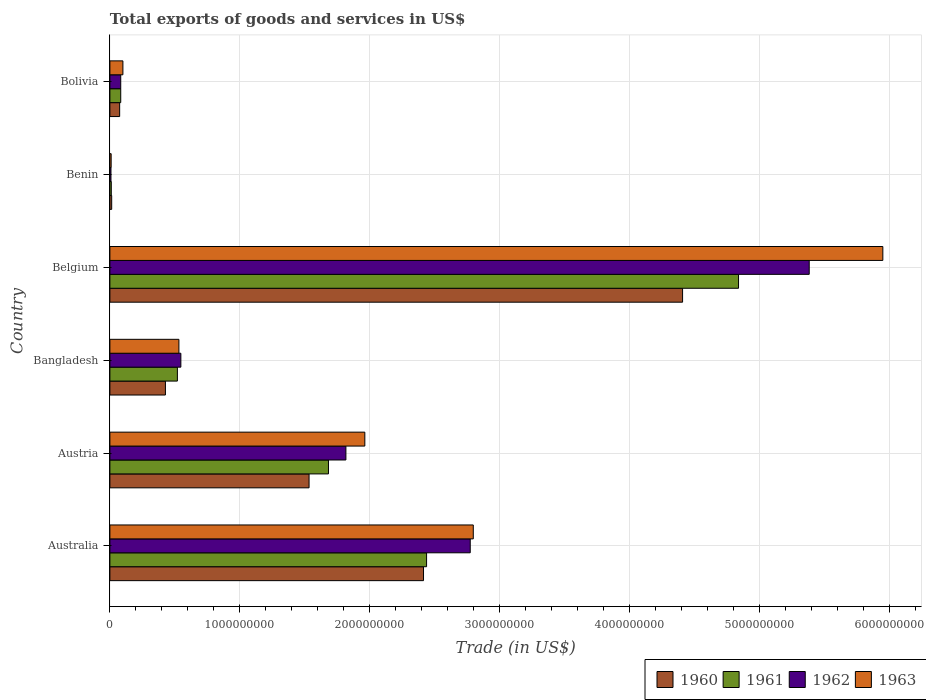How many different coloured bars are there?
Give a very brief answer. 4. How many groups of bars are there?
Keep it short and to the point. 6. Are the number of bars per tick equal to the number of legend labels?
Your answer should be compact. Yes. How many bars are there on the 2nd tick from the top?
Provide a succinct answer. 4. How many bars are there on the 3rd tick from the bottom?
Keep it short and to the point. 4. In how many cases, is the number of bars for a given country not equal to the number of legend labels?
Offer a terse response. 0. What is the total exports of goods and services in 1962 in Bangladesh?
Offer a terse response. 5.46e+08. Across all countries, what is the maximum total exports of goods and services in 1963?
Offer a very short reply. 5.95e+09. Across all countries, what is the minimum total exports of goods and services in 1963?
Keep it short and to the point. 9.70e+06. In which country was the total exports of goods and services in 1962 minimum?
Give a very brief answer. Benin. What is the total total exports of goods and services in 1962 in the graph?
Make the answer very short. 1.06e+1. What is the difference between the total exports of goods and services in 1962 in Benin and that in Bolivia?
Your answer should be very brief. -7.52e+07. What is the difference between the total exports of goods and services in 1961 in Bangladesh and the total exports of goods and services in 1963 in Australia?
Offer a terse response. -2.28e+09. What is the average total exports of goods and services in 1961 per country?
Offer a very short reply. 1.60e+09. What is the difference between the total exports of goods and services in 1960 and total exports of goods and services in 1962 in Austria?
Provide a succinct answer. -2.84e+08. In how many countries, is the total exports of goods and services in 1962 greater than 2600000000 US$?
Give a very brief answer. 2. What is the ratio of the total exports of goods and services in 1963 in Australia to that in Benin?
Your response must be concise. 288.2. Is the difference between the total exports of goods and services in 1960 in Belgium and Benin greater than the difference between the total exports of goods and services in 1962 in Belgium and Benin?
Keep it short and to the point. No. What is the difference between the highest and the second highest total exports of goods and services in 1960?
Offer a terse response. 1.99e+09. What is the difference between the highest and the lowest total exports of goods and services in 1962?
Make the answer very short. 5.37e+09. Is it the case that in every country, the sum of the total exports of goods and services in 1961 and total exports of goods and services in 1963 is greater than the sum of total exports of goods and services in 1962 and total exports of goods and services in 1960?
Your answer should be compact. No. What does the 1st bar from the top in Australia represents?
Provide a short and direct response. 1963. What does the 4th bar from the bottom in Bangladesh represents?
Offer a terse response. 1963. How many bars are there?
Provide a succinct answer. 24. How many countries are there in the graph?
Provide a short and direct response. 6. What is the difference between two consecutive major ticks on the X-axis?
Your answer should be compact. 1.00e+09. Does the graph contain any zero values?
Provide a short and direct response. No. Where does the legend appear in the graph?
Offer a terse response. Bottom right. What is the title of the graph?
Your answer should be compact. Total exports of goods and services in US$. What is the label or title of the X-axis?
Your answer should be compact. Trade (in US$). What is the label or title of the Y-axis?
Provide a short and direct response. Country. What is the Trade (in US$) in 1960 in Australia?
Your answer should be very brief. 2.41e+09. What is the Trade (in US$) in 1961 in Australia?
Offer a terse response. 2.44e+09. What is the Trade (in US$) in 1962 in Australia?
Give a very brief answer. 2.77e+09. What is the Trade (in US$) of 1963 in Australia?
Your response must be concise. 2.80e+09. What is the Trade (in US$) in 1960 in Austria?
Provide a succinct answer. 1.53e+09. What is the Trade (in US$) of 1961 in Austria?
Your answer should be very brief. 1.68e+09. What is the Trade (in US$) in 1962 in Austria?
Your response must be concise. 1.82e+09. What is the Trade (in US$) of 1963 in Austria?
Offer a terse response. 1.96e+09. What is the Trade (in US$) in 1960 in Bangladesh?
Provide a succinct answer. 4.27e+08. What is the Trade (in US$) in 1961 in Bangladesh?
Your response must be concise. 5.19e+08. What is the Trade (in US$) in 1962 in Bangladesh?
Provide a succinct answer. 5.46e+08. What is the Trade (in US$) in 1963 in Bangladesh?
Your answer should be very brief. 5.31e+08. What is the Trade (in US$) in 1960 in Belgium?
Your answer should be compact. 4.41e+09. What is the Trade (in US$) of 1961 in Belgium?
Offer a terse response. 4.84e+09. What is the Trade (in US$) in 1962 in Belgium?
Give a very brief answer. 5.38e+09. What is the Trade (in US$) in 1963 in Belgium?
Offer a very short reply. 5.95e+09. What is the Trade (in US$) in 1960 in Benin?
Make the answer very short. 1.39e+07. What is the Trade (in US$) in 1961 in Benin?
Make the answer very short. 1.08e+07. What is the Trade (in US$) in 1962 in Benin?
Offer a terse response. 8.32e+06. What is the Trade (in US$) in 1963 in Benin?
Ensure brevity in your answer.  9.70e+06. What is the Trade (in US$) of 1960 in Bolivia?
Offer a very short reply. 7.51e+07. What is the Trade (in US$) in 1961 in Bolivia?
Keep it short and to the point. 8.35e+07. What is the Trade (in US$) in 1962 in Bolivia?
Your answer should be very brief. 8.35e+07. What is the Trade (in US$) in 1963 in Bolivia?
Give a very brief answer. 1.00e+08. Across all countries, what is the maximum Trade (in US$) in 1960?
Offer a terse response. 4.41e+09. Across all countries, what is the maximum Trade (in US$) of 1961?
Give a very brief answer. 4.84e+09. Across all countries, what is the maximum Trade (in US$) in 1962?
Offer a very short reply. 5.38e+09. Across all countries, what is the maximum Trade (in US$) in 1963?
Your response must be concise. 5.95e+09. Across all countries, what is the minimum Trade (in US$) of 1960?
Ensure brevity in your answer.  1.39e+07. Across all countries, what is the minimum Trade (in US$) of 1961?
Make the answer very short. 1.08e+07. Across all countries, what is the minimum Trade (in US$) of 1962?
Make the answer very short. 8.32e+06. Across all countries, what is the minimum Trade (in US$) in 1963?
Your answer should be compact. 9.70e+06. What is the total Trade (in US$) of 1960 in the graph?
Your response must be concise. 8.87e+09. What is the total Trade (in US$) in 1961 in the graph?
Offer a terse response. 9.57e+09. What is the total Trade (in US$) of 1962 in the graph?
Offer a very short reply. 1.06e+1. What is the total Trade (in US$) in 1963 in the graph?
Provide a succinct answer. 1.13e+1. What is the difference between the Trade (in US$) in 1960 in Australia and that in Austria?
Give a very brief answer. 8.81e+08. What is the difference between the Trade (in US$) in 1961 in Australia and that in Austria?
Ensure brevity in your answer.  7.55e+08. What is the difference between the Trade (in US$) of 1962 in Australia and that in Austria?
Your response must be concise. 9.57e+08. What is the difference between the Trade (in US$) in 1963 in Australia and that in Austria?
Your response must be concise. 8.35e+08. What is the difference between the Trade (in US$) of 1960 in Australia and that in Bangladesh?
Ensure brevity in your answer.  1.99e+09. What is the difference between the Trade (in US$) in 1961 in Australia and that in Bangladesh?
Your answer should be compact. 1.92e+09. What is the difference between the Trade (in US$) of 1962 in Australia and that in Bangladesh?
Your response must be concise. 2.23e+09. What is the difference between the Trade (in US$) of 1963 in Australia and that in Bangladesh?
Offer a very short reply. 2.27e+09. What is the difference between the Trade (in US$) of 1960 in Australia and that in Belgium?
Offer a very short reply. -1.99e+09. What is the difference between the Trade (in US$) in 1961 in Australia and that in Belgium?
Provide a succinct answer. -2.40e+09. What is the difference between the Trade (in US$) in 1962 in Australia and that in Belgium?
Your response must be concise. -2.61e+09. What is the difference between the Trade (in US$) of 1963 in Australia and that in Belgium?
Keep it short and to the point. -3.15e+09. What is the difference between the Trade (in US$) of 1960 in Australia and that in Benin?
Ensure brevity in your answer.  2.40e+09. What is the difference between the Trade (in US$) in 1961 in Australia and that in Benin?
Offer a very short reply. 2.43e+09. What is the difference between the Trade (in US$) in 1962 in Australia and that in Benin?
Your response must be concise. 2.76e+09. What is the difference between the Trade (in US$) of 1963 in Australia and that in Benin?
Ensure brevity in your answer.  2.79e+09. What is the difference between the Trade (in US$) of 1960 in Australia and that in Bolivia?
Your answer should be compact. 2.34e+09. What is the difference between the Trade (in US$) in 1961 in Australia and that in Bolivia?
Make the answer very short. 2.35e+09. What is the difference between the Trade (in US$) of 1962 in Australia and that in Bolivia?
Provide a succinct answer. 2.69e+09. What is the difference between the Trade (in US$) of 1963 in Australia and that in Bolivia?
Offer a very short reply. 2.70e+09. What is the difference between the Trade (in US$) of 1960 in Austria and that in Bangladesh?
Ensure brevity in your answer.  1.11e+09. What is the difference between the Trade (in US$) of 1961 in Austria and that in Bangladesh?
Give a very brief answer. 1.16e+09. What is the difference between the Trade (in US$) of 1962 in Austria and that in Bangladesh?
Provide a succinct answer. 1.27e+09. What is the difference between the Trade (in US$) in 1963 in Austria and that in Bangladesh?
Keep it short and to the point. 1.43e+09. What is the difference between the Trade (in US$) of 1960 in Austria and that in Belgium?
Provide a short and direct response. -2.87e+09. What is the difference between the Trade (in US$) of 1961 in Austria and that in Belgium?
Make the answer very short. -3.16e+09. What is the difference between the Trade (in US$) of 1962 in Austria and that in Belgium?
Your response must be concise. -3.57e+09. What is the difference between the Trade (in US$) in 1963 in Austria and that in Belgium?
Give a very brief answer. -3.99e+09. What is the difference between the Trade (in US$) of 1960 in Austria and that in Benin?
Provide a short and direct response. 1.52e+09. What is the difference between the Trade (in US$) in 1961 in Austria and that in Benin?
Offer a very short reply. 1.67e+09. What is the difference between the Trade (in US$) in 1962 in Austria and that in Benin?
Keep it short and to the point. 1.81e+09. What is the difference between the Trade (in US$) in 1963 in Austria and that in Benin?
Provide a short and direct response. 1.95e+09. What is the difference between the Trade (in US$) in 1960 in Austria and that in Bolivia?
Offer a terse response. 1.46e+09. What is the difference between the Trade (in US$) in 1961 in Austria and that in Bolivia?
Give a very brief answer. 1.60e+09. What is the difference between the Trade (in US$) of 1962 in Austria and that in Bolivia?
Keep it short and to the point. 1.73e+09. What is the difference between the Trade (in US$) of 1963 in Austria and that in Bolivia?
Offer a very short reply. 1.86e+09. What is the difference between the Trade (in US$) of 1960 in Bangladesh and that in Belgium?
Keep it short and to the point. -3.98e+09. What is the difference between the Trade (in US$) of 1961 in Bangladesh and that in Belgium?
Offer a very short reply. -4.32e+09. What is the difference between the Trade (in US$) of 1962 in Bangladesh and that in Belgium?
Keep it short and to the point. -4.84e+09. What is the difference between the Trade (in US$) in 1963 in Bangladesh and that in Belgium?
Offer a very short reply. -5.42e+09. What is the difference between the Trade (in US$) in 1960 in Bangladesh and that in Benin?
Give a very brief answer. 4.13e+08. What is the difference between the Trade (in US$) of 1961 in Bangladesh and that in Benin?
Give a very brief answer. 5.09e+08. What is the difference between the Trade (in US$) in 1962 in Bangladesh and that in Benin?
Provide a succinct answer. 5.38e+08. What is the difference between the Trade (in US$) of 1963 in Bangladesh and that in Benin?
Offer a terse response. 5.21e+08. What is the difference between the Trade (in US$) of 1960 in Bangladesh and that in Bolivia?
Keep it short and to the point. 3.52e+08. What is the difference between the Trade (in US$) in 1961 in Bangladesh and that in Bolivia?
Offer a terse response. 4.36e+08. What is the difference between the Trade (in US$) in 1962 in Bangladesh and that in Bolivia?
Your response must be concise. 4.63e+08. What is the difference between the Trade (in US$) of 1963 in Bangladesh and that in Bolivia?
Ensure brevity in your answer.  4.31e+08. What is the difference between the Trade (in US$) of 1960 in Belgium and that in Benin?
Offer a very short reply. 4.39e+09. What is the difference between the Trade (in US$) in 1961 in Belgium and that in Benin?
Your response must be concise. 4.83e+09. What is the difference between the Trade (in US$) in 1962 in Belgium and that in Benin?
Keep it short and to the point. 5.37e+09. What is the difference between the Trade (in US$) of 1963 in Belgium and that in Benin?
Your response must be concise. 5.94e+09. What is the difference between the Trade (in US$) in 1960 in Belgium and that in Bolivia?
Provide a short and direct response. 4.33e+09. What is the difference between the Trade (in US$) in 1961 in Belgium and that in Bolivia?
Your response must be concise. 4.75e+09. What is the difference between the Trade (in US$) of 1962 in Belgium and that in Bolivia?
Make the answer very short. 5.30e+09. What is the difference between the Trade (in US$) of 1963 in Belgium and that in Bolivia?
Ensure brevity in your answer.  5.85e+09. What is the difference between the Trade (in US$) in 1960 in Benin and that in Bolivia?
Your answer should be compact. -6.13e+07. What is the difference between the Trade (in US$) of 1961 in Benin and that in Bolivia?
Provide a short and direct response. -7.27e+07. What is the difference between the Trade (in US$) of 1962 in Benin and that in Bolivia?
Offer a terse response. -7.52e+07. What is the difference between the Trade (in US$) in 1963 in Benin and that in Bolivia?
Ensure brevity in your answer.  -9.05e+07. What is the difference between the Trade (in US$) of 1960 in Australia and the Trade (in US$) of 1961 in Austria?
Provide a succinct answer. 7.31e+08. What is the difference between the Trade (in US$) in 1960 in Australia and the Trade (in US$) in 1962 in Austria?
Give a very brief answer. 5.97e+08. What is the difference between the Trade (in US$) of 1960 in Australia and the Trade (in US$) of 1963 in Austria?
Give a very brief answer. 4.52e+08. What is the difference between the Trade (in US$) of 1961 in Australia and the Trade (in US$) of 1962 in Austria?
Offer a very short reply. 6.21e+08. What is the difference between the Trade (in US$) in 1961 in Australia and the Trade (in US$) in 1963 in Austria?
Offer a terse response. 4.75e+08. What is the difference between the Trade (in US$) in 1962 in Australia and the Trade (in US$) in 1963 in Austria?
Your answer should be compact. 8.11e+08. What is the difference between the Trade (in US$) in 1960 in Australia and the Trade (in US$) in 1961 in Bangladesh?
Provide a succinct answer. 1.89e+09. What is the difference between the Trade (in US$) of 1960 in Australia and the Trade (in US$) of 1962 in Bangladesh?
Provide a succinct answer. 1.87e+09. What is the difference between the Trade (in US$) of 1960 in Australia and the Trade (in US$) of 1963 in Bangladesh?
Your answer should be very brief. 1.88e+09. What is the difference between the Trade (in US$) of 1961 in Australia and the Trade (in US$) of 1962 in Bangladesh?
Your response must be concise. 1.89e+09. What is the difference between the Trade (in US$) of 1961 in Australia and the Trade (in US$) of 1963 in Bangladesh?
Keep it short and to the point. 1.91e+09. What is the difference between the Trade (in US$) in 1962 in Australia and the Trade (in US$) in 1963 in Bangladesh?
Your response must be concise. 2.24e+09. What is the difference between the Trade (in US$) in 1960 in Australia and the Trade (in US$) in 1961 in Belgium?
Offer a very short reply. -2.42e+09. What is the difference between the Trade (in US$) of 1960 in Australia and the Trade (in US$) of 1962 in Belgium?
Ensure brevity in your answer.  -2.97e+09. What is the difference between the Trade (in US$) in 1960 in Australia and the Trade (in US$) in 1963 in Belgium?
Your answer should be compact. -3.53e+09. What is the difference between the Trade (in US$) of 1961 in Australia and the Trade (in US$) of 1962 in Belgium?
Make the answer very short. -2.94e+09. What is the difference between the Trade (in US$) of 1961 in Australia and the Trade (in US$) of 1963 in Belgium?
Ensure brevity in your answer.  -3.51e+09. What is the difference between the Trade (in US$) of 1962 in Australia and the Trade (in US$) of 1963 in Belgium?
Your answer should be compact. -3.18e+09. What is the difference between the Trade (in US$) in 1960 in Australia and the Trade (in US$) in 1961 in Benin?
Ensure brevity in your answer.  2.40e+09. What is the difference between the Trade (in US$) of 1960 in Australia and the Trade (in US$) of 1962 in Benin?
Make the answer very short. 2.41e+09. What is the difference between the Trade (in US$) in 1960 in Australia and the Trade (in US$) in 1963 in Benin?
Provide a succinct answer. 2.40e+09. What is the difference between the Trade (in US$) of 1961 in Australia and the Trade (in US$) of 1962 in Benin?
Your answer should be compact. 2.43e+09. What is the difference between the Trade (in US$) of 1961 in Australia and the Trade (in US$) of 1963 in Benin?
Provide a short and direct response. 2.43e+09. What is the difference between the Trade (in US$) in 1962 in Australia and the Trade (in US$) in 1963 in Benin?
Make the answer very short. 2.76e+09. What is the difference between the Trade (in US$) of 1960 in Australia and the Trade (in US$) of 1961 in Bolivia?
Provide a short and direct response. 2.33e+09. What is the difference between the Trade (in US$) of 1960 in Australia and the Trade (in US$) of 1962 in Bolivia?
Keep it short and to the point. 2.33e+09. What is the difference between the Trade (in US$) of 1960 in Australia and the Trade (in US$) of 1963 in Bolivia?
Your answer should be compact. 2.31e+09. What is the difference between the Trade (in US$) of 1961 in Australia and the Trade (in US$) of 1962 in Bolivia?
Provide a short and direct response. 2.35e+09. What is the difference between the Trade (in US$) of 1961 in Australia and the Trade (in US$) of 1963 in Bolivia?
Offer a very short reply. 2.34e+09. What is the difference between the Trade (in US$) of 1962 in Australia and the Trade (in US$) of 1963 in Bolivia?
Give a very brief answer. 2.67e+09. What is the difference between the Trade (in US$) in 1960 in Austria and the Trade (in US$) in 1961 in Bangladesh?
Offer a very short reply. 1.01e+09. What is the difference between the Trade (in US$) of 1960 in Austria and the Trade (in US$) of 1962 in Bangladesh?
Provide a short and direct response. 9.87e+08. What is the difference between the Trade (in US$) in 1960 in Austria and the Trade (in US$) in 1963 in Bangladesh?
Your answer should be compact. 1.00e+09. What is the difference between the Trade (in US$) of 1961 in Austria and the Trade (in US$) of 1962 in Bangladesh?
Ensure brevity in your answer.  1.14e+09. What is the difference between the Trade (in US$) in 1961 in Austria and the Trade (in US$) in 1963 in Bangladesh?
Your response must be concise. 1.15e+09. What is the difference between the Trade (in US$) in 1962 in Austria and the Trade (in US$) in 1963 in Bangladesh?
Offer a very short reply. 1.29e+09. What is the difference between the Trade (in US$) in 1960 in Austria and the Trade (in US$) in 1961 in Belgium?
Provide a short and direct response. -3.31e+09. What is the difference between the Trade (in US$) of 1960 in Austria and the Trade (in US$) of 1962 in Belgium?
Ensure brevity in your answer.  -3.85e+09. What is the difference between the Trade (in US$) in 1960 in Austria and the Trade (in US$) in 1963 in Belgium?
Ensure brevity in your answer.  -4.42e+09. What is the difference between the Trade (in US$) in 1961 in Austria and the Trade (in US$) in 1962 in Belgium?
Provide a short and direct response. -3.70e+09. What is the difference between the Trade (in US$) in 1961 in Austria and the Trade (in US$) in 1963 in Belgium?
Provide a succinct answer. -4.27e+09. What is the difference between the Trade (in US$) of 1962 in Austria and the Trade (in US$) of 1963 in Belgium?
Keep it short and to the point. -4.13e+09. What is the difference between the Trade (in US$) in 1960 in Austria and the Trade (in US$) in 1961 in Benin?
Give a very brief answer. 1.52e+09. What is the difference between the Trade (in US$) of 1960 in Austria and the Trade (in US$) of 1962 in Benin?
Provide a succinct answer. 1.52e+09. What is the difference between the Trade (in US$) in 1960 in Austria and the Trade (in US$) in 1963 in Benin?
Give a very brief answer. 1.52e+09. What is the difference between the Trade (in US$) in 1961 in Austria and the Trade (in US$) in 1962 in Benin?
Give a very brief answer. 1.67e+09. What is the difference between the Trade (in US$) in 1961 in Austria and the Trade (in US$) in 1963 in Benin?
Provide a succinct answer. 1.67e+09. What is the difference between the Trade (in US$) of 1962 in Austria and the Trade (in US$) of 1963 in Benin?
Provide a succinct answer. 1.81e+09. What is the difference between the Trade (in US$) in 1960 in Austria and the Trade (in US$) in 1961 in Bolivia?
Your answer should be compact. 1.45e+09. What is the difference between the Trade (in US$) in 1960 in Austria and the Trade (in US$) in 1962 in Bolivia?
Give a very brief answer. 1.45e+09. What is the difference between the Trade (in US$) in 1960 in Austria and the Trade (in US$) in 1963 in Bolivia?
Give a very brief answer. 1.43e+09. What is the difference between the Trade (in US$) in 1961 in Austria and the Trade (in US$) in 1962 in Bolivia?
Provide a short and direct response. 1.60e+09. What is the difference between the Trade (in US$) of 1961 in Austria and the Trade (in US$) of 1963 in Bolivia?
Your answer should be compact. 1.58e+09. What is the difference between the Trade (in US$) in 1962 in Austria and the Trade (in US$) in 1963 in Bolivia?
Provide a succinct answer. 1.72e+09. What is the difference between the Trade (in US$) in 1960 in Bangladesh and the Trade (in US$) in 1961 in Belgium?
Your answer should be compact. -4.41e+09. What is the difference between the Trade (in US$) of 1960 in Bangladesh and the Trade (in US$) of 1962 in Belgium?
Provide a succinct answer. -4.95e+09. What is the difference between the Trade (in US$) of 1960 in Bangladesh and the Trade (in US$) of 1963 in Belgium?
Make the answer very short. -5.52e+09. What is the difference between the Trade (in US$) in 1961 in Bangladesh and the Trade (in US$) in 1962 in Belgium?
Your answer should be compact. -4.86e+09. What is the difference between the Trade (in US$) in 1961 in Bangladesh and the Trade (in US$) in 1963 in Belgium?
Provide a short and direct response. -5.43e+09. What is the difference between the Trade (in US$) of 1962 in Bangladesh and the Trade (in US$) of 1963 in Belgium?
Provide a succinct answer. -5.40e+09. What is the difference between the Trade (in US$) of 1960 in Bangladesh and the Trade (in US$) of 1961 in Benin?
Your answer should be compact. 4.17e+08. What is the difference between the Trade (in US$) in 1960 in Bangladesh and the Trade (in US$) in 1962 in Benin?
Your response must be concise. 4.19e+08. What is the difference between the Trade (in US$) in 1960 in Bangladesh and the Trade (in US$) in 1963 in Benin?
Your answer should be very brief. 4.18e+08. What is the difference between the Trade (in US$) of 1961 in Bangladesh and the Trade (in US$) of 1962 in Benin?
Keep it short and to the point. 5.11e+08. What is the difference between the Trade (in US$) in 1961 in Bangladesh and the Trade (in US$) in 1963 in Benin?
Your response must be concise. 5.10e+08. What is the difference between the Trade (in US$) in 1962 in Bangladesh and the Trade (in US$) in 1963 in Benin?
Ensure brevity in your answer.  5.36e+08. What is the difference between the Trade (in US$) of 1960 in Bangladesh and the Trade (in US$) of 1961 in Bolivia?
Offer a very short reply. 3.44e+08. What is the difference between the Trade (in US$) in 1960 in Bangladesh and the Trade (in US$) in 1962 in Bolivia?
Provide a short and direct response. 3.44e+08. What is the difference between the Trade (in US$) of 1960 in Bangladesh and the Trade (in US$) of 1963 in Bolivia?
Offer a very short reply. 3.27e+08. What is the difference between the Trade (in US$) of 1961 in Bangladesh and the Trade (in US$) of 1962 in Bolivia?
Provide a short and direct response. 4.36e+08. What is the difference between the Trade (in US$) in 1961 in Bangladesh and the Trade (in US$) in 1963 in Bolivia?
Make the answer very short. 4.19e+08. What is the difference between the Trade (in US$) of 1962 in Bangladesh and the Trade (in US$) of 1963 in Bolivia?
Ensure brevity in your answer.  4.46e+08. What is the difference between the Trade (in US$) of 1960 in Belgium and the Trade (in US$) of 1961 in Benin?
Offer a very short reply. 4.40e+09. What is the difference between the Trade (in US$) of 1960 in Belgium and the Trade (in US$) of 1962 in Benin?
Offer a terse response. 4.40e+09. What is the difference between the Trade (in US$) of 1960 in Belgium and the Trade (in US$) of 1963 in Benin?
Ensure brevity in your answer.  4.40e+09. What is the difference between the Trade (in US$) in 1961 in Belgium and the Trade (in US$) in 1962 in Benin?
Keep it short and to the point. 4.83e+09. What is the difference between the Trade (in US$) in 1961 in Belgium and the Trade (in US$) in 1963 in Benin?
Make the answer very short. 4.83e+09. What is the difference between the Trade (in US$) in 1962 in Belgium and the Trade (in US$) in 1963 in Benin?
Keep it short and to the point. 5.37e+09. What is the difference between the Trade (in US$) in 1960 in Belgium and the Trade (in US$) in 1961 in Bolivia?
Give a very brief answer. 4.32e+09. What is the difference between the Trade (in US$) in 1960 in Belgium and the Trade (in US$) in 1962 in Bolivia?
Your answer should be very brief. 4.32e+09. What is the difference between the Trade (in US$) in 1960 in Belgium and the Trade (in US$) in 1963 in Bolivia?
Provide a succinct answer. 4.31e+09. What is the difference between the Trade (in US$) in 1961 in Belgium and the Trade (in US$) in 1962 in Bolivia?
Ensure brevity in your answer.  4.75e+09. What is the difference between the Trade (in US$) of 1961 in Belgium and the Trade (in US$) of 1963 in Bolivia?
Give a very brief answer. 4.74e+09. What is the difference between the Trade (in US$) of 1962 in Belgium and the Trade (in US$) of 1963 in Bolivia?
Provide a succinct answer. 5.28e+09. What is the difference between the Trade (in US$) in 1960 in Benin and the Trade (in US$) in 1961 in Bolivia?
Your response must be concise. -6.96e+07. What is the difference between the Trade (in US$) of 1960 in Benin and the Trade (in US$) of 1962 in Bolivia?
Provide a succinct answer. -6.96e+07. What is the difference between the Trade (in US$) of 1960 in Benin and the Trade (in US$) of 1963 in Bolivia?
Provide a short and direct response. -8.63e+07. What is the difference between the Trade (in US$) of 1961 in Benin and the Trade (in US$) of 1962 in Bolivia?
Provide a short and direct response. -7.27e+07. What is the difference between the Trade (in US$) of 1961 in Benin and the Trade (in US$) of 1963 in Bolivia?
Provide a short and direct response. -8.94e+07. What is the difference between the Trade (in US$) in 1962 in Benin and the Trade (in US$) in 1963 in Bolivia?
Ensure brevity in your answer.  -9.19e+07. What is the average Trade (in US$) of 1960 per country?
Ensure brevity in your answer.  1.48e+09. What is the average Trade (in US$) of 1961 per country?
Keep it short and to the point. 1.60e+09. What is the average Trade (in US$) in 1962 per country?
Make the answer very short. 1.77e+09. What is the average Trade (in US$) of 1963 per country?
Keep it short and to the point. 1.89e+09. What is the difference between the Trade (in US$) in 1960 and Trade (in US$) in 1961 in Australia?
Provide a succinct answer. -2.35e+07. What is the difference between the Trade (in US$) in 1960 and Trade (in US$) in 1962 in Australia?
Offer a terse response. -3.60e+08. What is the difference between the Trade (in US$) in 1960 and Trade (in US$) in 1963 in Australia?
Give a very brief answer. -3.83e+08. What is the difference between the Trade (in US$) of 1961 and Trade (in US$) of 1962 in Australia?
Your answer should be very brief. -3.36e+08. What is the difference between the Trade (in US$) in 1961 and Trade (in US$) in 1963 in Australia?
Your answer should be compact. -3.60e+08. What is the difference between the Trade (in US$) of 1962 and Trade (in US$) of 1963 in Australia?
Ensure brevity in your answer.  -2.35e+07. What is the difference between the Trade (in US$) in 1960 and Trade (in US$) in 1961 in Austria?
Offer a terse response. -1.49e+08. What is the difference between the Trade (in US$) in 1960 and Trade (in US$) in 1962 in Austria?
Your answer should be very brief. -2.84e+08. What is the difference between the Trade (in US$) of 1960 and Trade (in US$) of 1963 in Austria?
Offer a terse response. -4.29e+08. What is the difference between the Trade (in US$) in 1961 and Trade (in US$) in 1962 in Austria?
Your answer should be compact. -1.34e+08. What is the difference between the Trade (in US$) in 1961 and Trade (in US$) in 1963 in Austria?
Provide a succinct answer. -2.80e+08. What is the difference between the Trade (in US$) in 1962 and Trade (in US$) in 1963 in Austria?
Your answer should be compact. -1.46e+08. What is the difference between the Trade (in US$) of 1960 and Trade (in US$) of 1961 in Bangladesh?
Provide a short and direct response. -9.21e+07. What is the difference between the Trade (in US$) in 1960 and Trade (in US$) in 1962 in Bangladesh?
Keep it short and to the point. -1.19e+08. What is the difference between the Trade (in US$) in 1960 and Trade (in US$) in 1963 in Bangladesh?
Offer a very short reply. -1.04e+08. What is the difference between the Trade (in US$) of 1961 and Trade (in US$) of 1962 in Bangladesh?
Keep it short and to the point. -2.66e+07. What is the difference between the Trade (in US$) in 1961 and Trade (in US$) in 1963 in Bangladesh?
Keep it short and to the point. -1.16e+07. What is the difference between the Trade (in US$) in 1962 and Trade (in US$) in 1963 in Bangladesh?
Ensure brevity in your answer.  1.50e+07. What is the difference between the Trade (in US$) in 1960 and Trade (in US$) in 1961 in Belgium?
Your response must be concise. -4.31e+08. What is the difference between the Trade (in US$) of 1960 and Trade (in US$) of 1962 in Belgium?
Your answer should be very brief. -9.75e+08. What is the difference between the Trade (in US$) in 1960 and Trade (in US$) in 1963 in Belgium?
Ensure brevity in your answer.  -1.54e+09. What is the difference between the Trade (in US$) in 1961 and Trade (in US$) in 1962 in Belgium?
Make the answer very short. -5.44e+08. What is the difference between the Trade (in US$) in 1961 and Trade (in US$) in 1963 in Belgium?
Ensure brevity in your answer.  -1.11e+09. What is the difference between the Trade (in US$) of 1962 and Trade (in US$) of 1963 in Belgium?
Offer a terse response. -5.67e+08. What is the difference between the Trade (in US$) in 1960 and Trade (in US$) in 1961 in Benin?
Ensure brevity in your answer.  3.05e+06. What is the difference between the Trade (in US$) in 1960 and Trade (in US$) in 1962 in Benin?
Provide a short and direct response. 5.53e+06. What is the difference between the Trade (in US$) in 1960 and Trade (in US$) in 1963 in Benin?
Your answer should be very brief. 4.15e+06. What is the difference between the Trade (in US$) of 1961 and Trade (in US$) of 1962 in Benin?
Give a very brief answer. 2.48e+06. What is the difference between the Trade (in US$) in 1961 and Trade (in US$) in 1963 in Benin?
Offer a terse response. 1.10e+06. What is the difference between the Trade (in US$) of 1962 and Trade (in US$) of 1963 in Benin?
Provide a succinct answer. -1.39e+06. What is the difference between the Trade (in US$) of 1960 and Trade (in US$) of 1961 in Bolivia?
Ensure brevity in your answer.  -8.35e+06. What is the difference between the Trade (in US$) of 1960 and Trade (in US$) of 1962 in Bolivia?
Give a very brief answer. -8.35e+06. What is the difference between the Trade (in US$) of 1960 and Trade (in US$) of 1963 in Bolivia?
Keep it short and to the point. -2.50e+07. What is the difference between the Trade (in US$) in 1961 and Trade (in US$) in 1962 in Bolivia?
Make the answer very short. 0. What is the difference between the Trade (in US$) of 1961 and Trade (in US$) of 1963 in Bolivia?
Give a very brief answer. -1.67e+07. What is the difference between the Trade (in US$) in 1962 and Trade (in US$) in 1963 in Bolivia?
Your response must be concise. -1.67e+07. What is the ratio of the Trade (in US$) of 1960 in Australia to that in Austria?
Ensure brevity in your answer.  1.57. What is the ratio of the Trade (in US$) of 1961 in Australia to that in Austria?
Keep it short and to the point. 1.45. What is the ratio of the Trade (in US$) in 1962 in Australia to that in Austria?
Make the answer very short. 1.53. What is the ratio of the Trade (in US$) in 1963 in Australia to that in Austria?
Ensure brevity in your answer.  1.43. What is the ratio of the Trade (in US$) of 1960 in Australia to that in Bangladesh?
Give a very brief answer. 5.65. What is the ratio of the Trade (in US$) in 1961 in Australia to that in Bangladesh?
Offer a terse response. 4.69. What is the ratio of the Trade (in US$) of 1962 in Australia to that in Bangladesh?
Provide a succinct answer. 5.08. What is the ratio of the Trade (in US$) of 1963 in Australia to that in Bangladesh?
Keep it short and to the point. 5.27. What is the ratio of the Trade (in US$) of 1960 in Australia to that in Belgium?
Your response must be concise. 0.55. What is the ratio of the Trade (in US$) in 1961 in Australia to that in Belgium?
Make the answer very short. 0.5. What is the ratio of the Trade (in US$) of 1962 in Australia to that in Belgium?
Offer a very short reply. 0.52. What is the ratio of the Trade (in US$) of 1963 in Australia to that in Belgium?
Provide a succinct answer. 0.47. What is the ratio of the Trade (in US$) of 1960 in Australia to that in Benin?
Your response must be concise. 174.23. What is the ratio of the Trade (in US$) of 1961 in Australia to that in Benin?
Your answer should be very brief. 225.61. What is the ratio of the Trade (in US$) of 1962 in Australia to that in Benin?
Your answer should be compact. 333.4. What is the ratio of the Trade (in US$) in 1963 in Australia to that in Benin?
Provide a succinct answer. 288.2. What is the ratio of the Trade (in US$) of 1960 in Australia to that in Bolivia?
Your response must be concise. 32.13. What is the ratio of the Trade (in US$) in 1961 in Australia to that in Bolivia?
Give a very brief answer. 29.19. What is the ratio of the Trade (in US$) in 1962 in Australia to that in Bolivia?
Offer a very short reply. 33.22. What is the ratio of the Trade (in US$) in 1963 in Australia to that in Bolivia?
Keep it short and to the point. 27.92. What is the ratio of the Trade (in US$) of 1960 in Austria to that in Bangladesh?
Provide a short and direct response. 3.59. What is the ratio of the Trade (in US$) in 1961 in Austria to that in Bangladesh?
Your answer should be compact. 3.24. What is the ratio of the Trade (in US$) of 1962 in Austria to that in Bangladesh?
Your response must be concise. 3.33. What is the ratio of the Trade (in US$) in 1963 in Austria to that in Bangladesh?
Make the answer very short. 3.69. What is the ratio of the Trade (in US$) in 1960 in Austria to that in Belgium?
Your response must be concise. 0.35. What is the ratio of the Trade (in US$) in 1961 in Austria to that in Belgium?
Ensure brevity in your answer.  0.35. What is the ratio of the Trade (in US$) in 1962 in Austria to that in Belgium?
Your answer should be compact. 0.34. What is the ratio of the Trade (in US$) in 1963 in Austria to that in Belgium?
Your answer should be compact. 0.33. What is the ratio of the Trade (in US$) of 1960 in Austria to that in Benin?
Keep it short and to the point. 110.65. What is the ratio of the Trade (in US$) of 1961 in Austria to that in Benin?
Provide a succinct answer. 155.72. What is the ratio of the Trade (in US$) of 1962 in Austria to that in Benin?
Your answer should be very brief. 218.36. What is the ratio of the Trade (in US$) of 1963 in Austria to that in Benin?
Provide a succinct answer. 202.17. What is the ratio of the Trade (in US$) of 1960 in Austria to that in Bolivia?
Your response must be concise. 20.4. What is the ratio of the Trade (in US$) of 1961 in Austria to that in Bolivia?
Keep it short and to the point. 20.15. What is the ratio of the Trade (in US$) in 1962 in Austria to that in Bolivia?
Give a very brief answer. 21.76. What is the ratio of the Trade (in US$) of 1963 in Austria to that in Bolivia?
Keep it short and to the point. 19.59. What is the ratio of the Trade (in US$) of 1960 in Bangladesh to that in Belgium?
Your answer should be very brief. 0.1. What is the ratio of the Trade (in US$) in 1961 in Bangladesh to that in Belgium?
Provide a succinct answer. 0.11. What is the ratio of the Trade (in US$) of 1962 in Bangladesh to that in Belgium?
Your response must be concise. 0.1. What is the ratio of the Trade (in US$) in 1963 in Bangladesh to that in Belgium?
Your response must be concise. 0.09. What is the ratio of the Trade (in US$) in 1960 in Bangladesh to that in Benin?
Ensure brevity in your answer.  30.85. What is the ratio of the Trade (in US$) of 1961 in Bangladesh to that in Benin?
Provide a succinct answer. 48.09. What is the ratio of the Trade (in US$) in 1962 in Bangladesh to that in Benin?
Provide a short and direct response. 65.66. What is the ratio of the Trade (in US$) in 1963 in Bangladesh to that in Benin?
Keep it short and to the point. 54.73. What is the ratio of the Trade (in US$) of 1960 in Bangladesh to that in Bolivia?
Give a very brief answer. 5.69. What is the ratio of the Trade (in US$) of 1961 in Bangladesh to that in Bolivia?
Offer a terse response. 6.22. What is the ratio of the Trade (in US$) in 1962 in Bangladesh to that in Bolivia?
Make the answer very short. 6.54. What is the ratio of the Trade (in US$) in 1963 in Bangladesh to that in Bolivia?
Your answer should be very brief. 5.3. What is the ratio of the Trade (in US$) in 1960 in Belgium to that in Benin?
Keep it short and to the point. 318.15. What is the ratio of the Trade (in US$) of 1961 in Belgium to that in Benin?
Ensure brevity in your answer.  447.86. What is the ratio of the Trade (in US$) in 1962 in Belgium to that in Benin?
Give a very brief answer. 647.03. What is the ratio of the Trade (in US$) of 1963 in Belgium to that in Benin?
Your answer should be compact. 613. What is the ratio of the Trade (in US$) in 1960 in Belgium to that in Bolivia?
Your answer should be compact. 58.66. What is the ratio of the Trade (in US$) of 1961 in Belgium to that in Bolivia?
Offer a terse response. 57.95. What is the ratio of the Trade (in US$) of 1962 in Belgium to that in Bolivia?
Give a very brief answer. 64.47. What is the ratio of the Trade (in US$) of 1963 in Belgium to that in Bolivia?
Offer a very short reply. 59.38. What is the ratio of the Trade (in US$) in 1960 in Benin to that in Bolivia?
Give a very brief answer. 0.18. What is the ratio of the Trade (in US$) in 1961 in Benin to that in Bolivia?
Offer a terse response. 0.13. What is the ratio of the Trade (in US$) in 1962 in Benin to that in Bolivia?
Give a very brief answer. 0.1. What is the ratio of the Trade (in US$) in 1963 in Benin to that in Bolivia?
Your answer should be compact. 0.1. What is the difference between the highest and the second highest Trade (in US$) in 1960?
Provide a short and direct response. 1.99e+09. What is the difference between the highest and the second highest Trade (in US$) of 1961?
Offer a very short reply. 2.40e+09. What is the difference between the highest and the second highest Trade (in US$) of 1962?
Your answer should be compact. 2.61e+09. What is the difference between the highest and the second highest Trade (in US$) in 1963?
Offer a terse response. 3.15e+09. What is the difference between the highest and the lowest Trade (in US$) of 1960?
Make the answer very short. 4.39e+09. What is the difference between the highest and the lowest Trade (in US$) of 1961?
Provide a succinct answer. 4.83e+09. What is the difference between the highest and the lowest Trade (in US$) in 1962?
Your answer should be compact. 5.37e+09. What is the difference between the highest and the lowest Trade (in US$) of 1963?
Make the answer very short. 5.94e+09. 